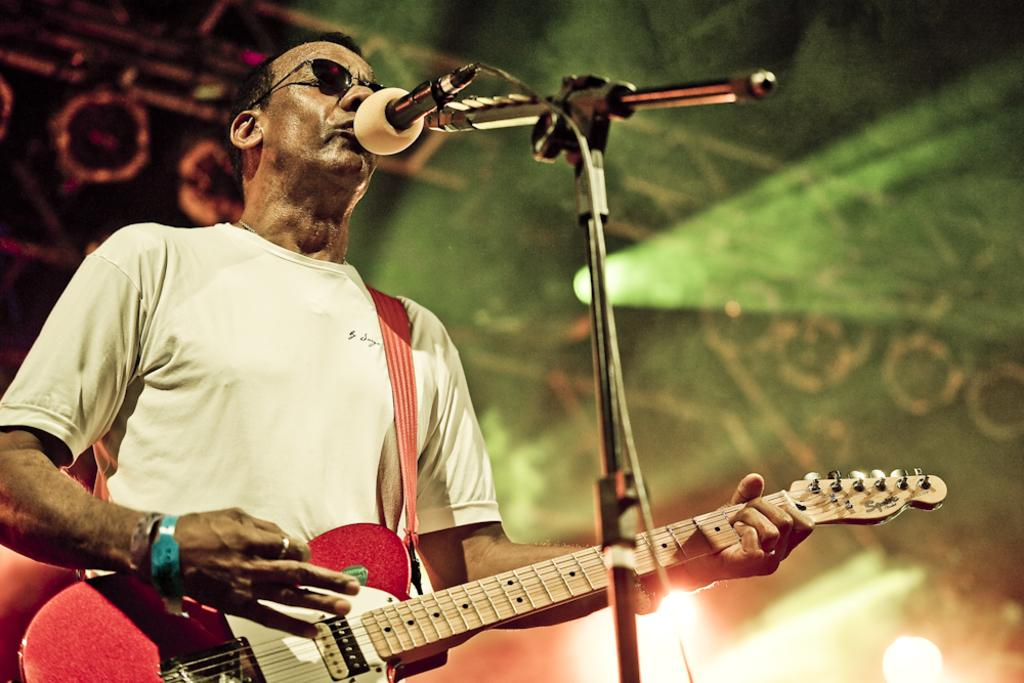What is the person in the image doing? The person is standing, playing a guitar, and singing. What object is the person using to amplify their voice? There is a microphone in the image. How many oranges are being used as a prop in the image? There are no oranges present in the image. What type of arch can be seen in the background of the image? There is no arch visible in the image. 